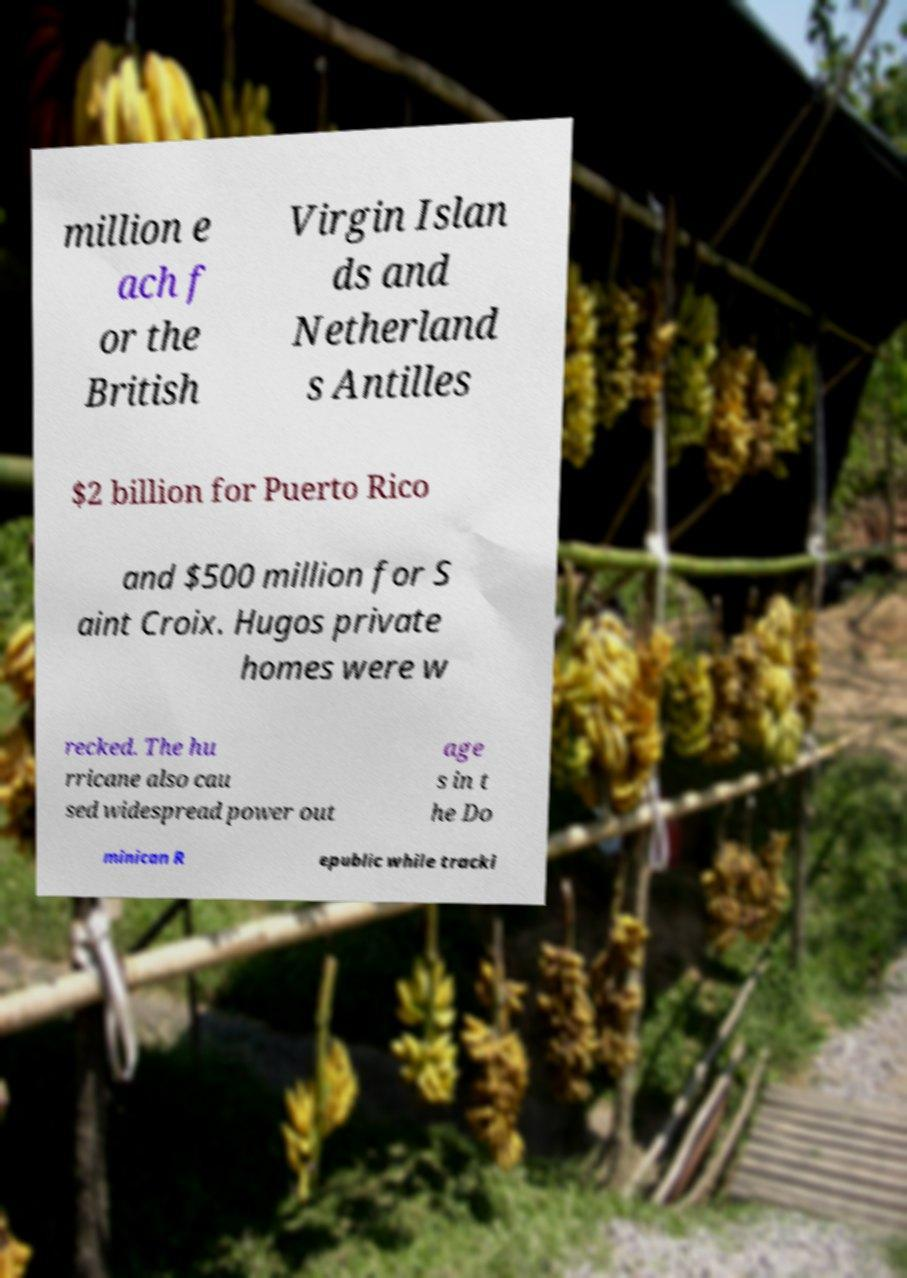There's text embedded in this image that I need extracted. Can you transcribe it verbatim? million e ach f or the British Virgin Islan ds and Netherland s Antilles $2 billion for Puerto Rico and $500 million for S aint Croix. Hugos private homes were w recked. The hu rricane also cau sed widespread power out age s in t he Do minican R epublic while tracki 